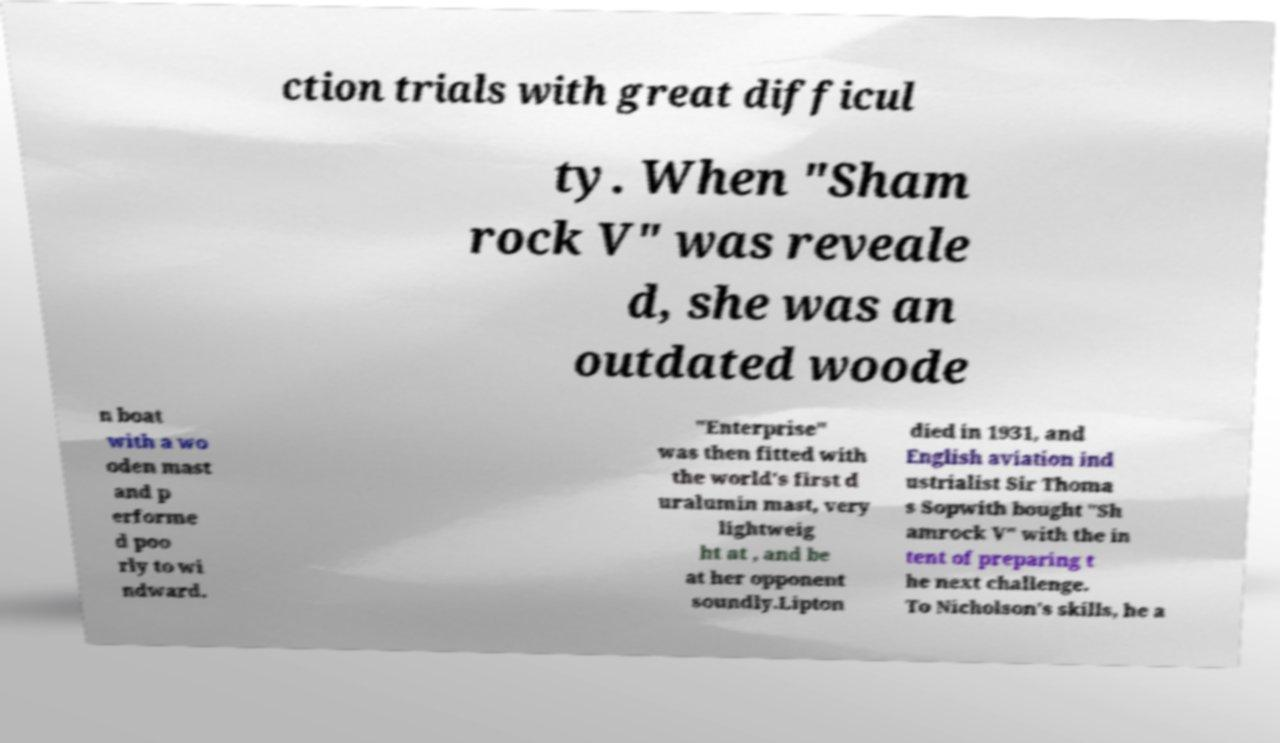I need the written content from this picture converted into text. Can you do that? ction trials with great difficul ty. When "Sham rock V" was reveale d, she was an outdated woode n boat with a wo oden mast and p erforme d poo rly to wi ndward. "Enterprise" was then fitted with the world's first d uralumin mast, very lightweig ht at , and be at her opponent soundly.Lipton died in 1931, and English aviation ind ustrialist Sir Thoma s Sopwith bought "Sh amrock V" with the in tent of preparing t he next challenge. To Nicholson's skills, he a 